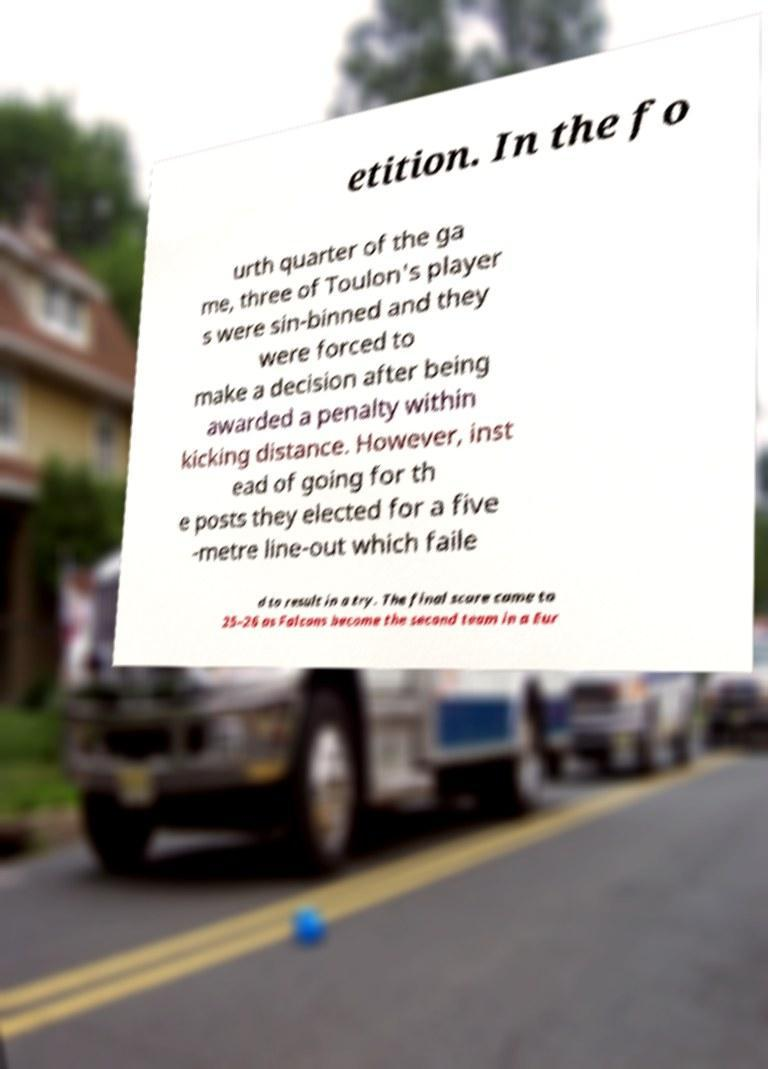Can you read and provide the text displayed in the image?This photo seems to have some interesting text. Can you extract and type it out for me? etition. In the fo urth quarter of the ga me, three of Toulon's player s were sin-binned and they were forced to make a decision after being awarded a penalty within kicking distance. However, inst ead of going for th e posts they elected for a five -metre line-out which faile d to result in a try. The final score came to 25–26 as Falcons become the second team in a Eur 